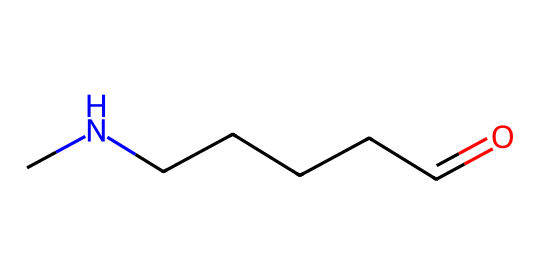What is the molecular structure of the polymer represented? The structure indicates it is nylon, as it includes an amide functional group (C(=O)N) that characterizes polyamides. The length of the carbon chain suggests it is part of a repeating unit in the polymer.
Answer: nylon How many carbon atoms are present in this structure? Counting the carbon atoms in the SMILES representation reveals there are six carbon atoms (C(=O)CCCCNC). This includes the carbon in the carbonyl (C=O) and four additional carbons in the chain plus one in the nitrogen-linkage.
Answer: six What type of polymer is indicated by this chemical structure? The presence of an amide bond directs us to identify this as a polyamide polymer, commonly associated with nylon. Polyamides typically have repeating units linked by amide bonds.
Answer: polyamide How many total atoms are in this molecular structure? By adding up all the atoms from the structure: 6 carbon, 11 hydrogen, 1 oxygen, and 1 nitrogen, it totals 19 atoms.
Answer: nineteen What type of bond connects the carbonyl carbon to the nitrogen atom in this structure? The bond connecting the carbonyl carbon to the nitrogen is a covalent bond, specifically an amide bond. This bond is critical for the polymer's structure and properties.
Answer: covalent Does this chemical structure suggest hydrophilic or hydrophobic characteristics? The presence of the amide functional group suggests hydrophilic characteristics due to its ability to form hydrogen bonds with water. Conversely, the long carbon chain indicates some hydrophobic properties.
Answer: hydrophilic 